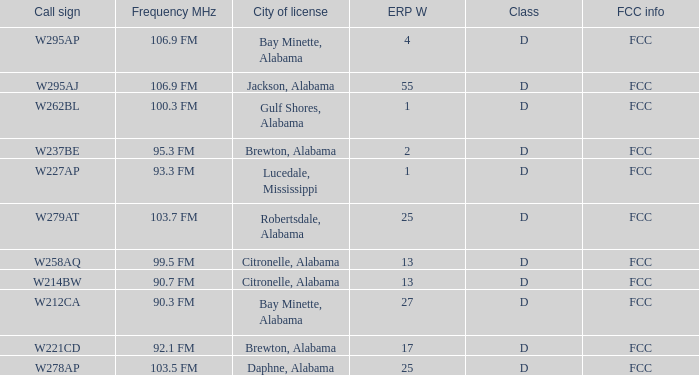Name the call sign for ERP W of 27 W212CA. 